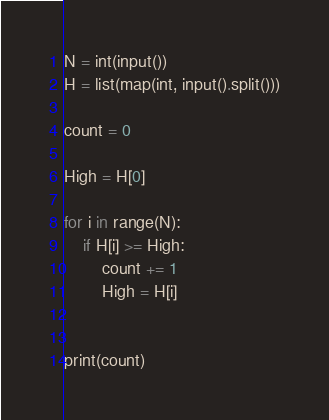<code> <loc_0><loc_0><loc_500><loc_500><_Python_>N = int(input())
H = list(map(int, input().split()))

count = 0

High = H[0]

for i in range(N):
	if H[i] >= High:
		count += 1
		High = H[i]
		

print(count)
</code> 